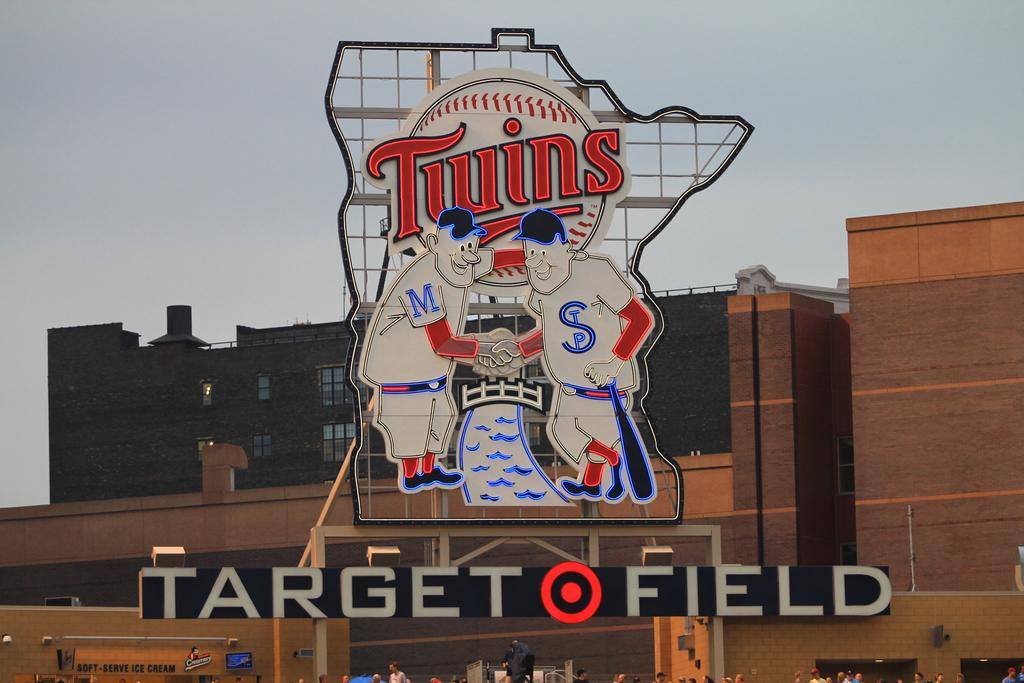What is the main object in the image that displays information? There is a name board in the image. What other signage can be seen in the image? There is a hoarding in the image. Can you describe the people in the image? There is a group of people in the image. What else can be seen in the image besides the people and signage? There are objects in the image. What type of building is visible in the image? There is a building with windows in the image. What is visible in the background of the image? The sky is visible in the background of the image. What type of pin is being used to hold the dinner in the image? There is no dinner or pin present in the image. 